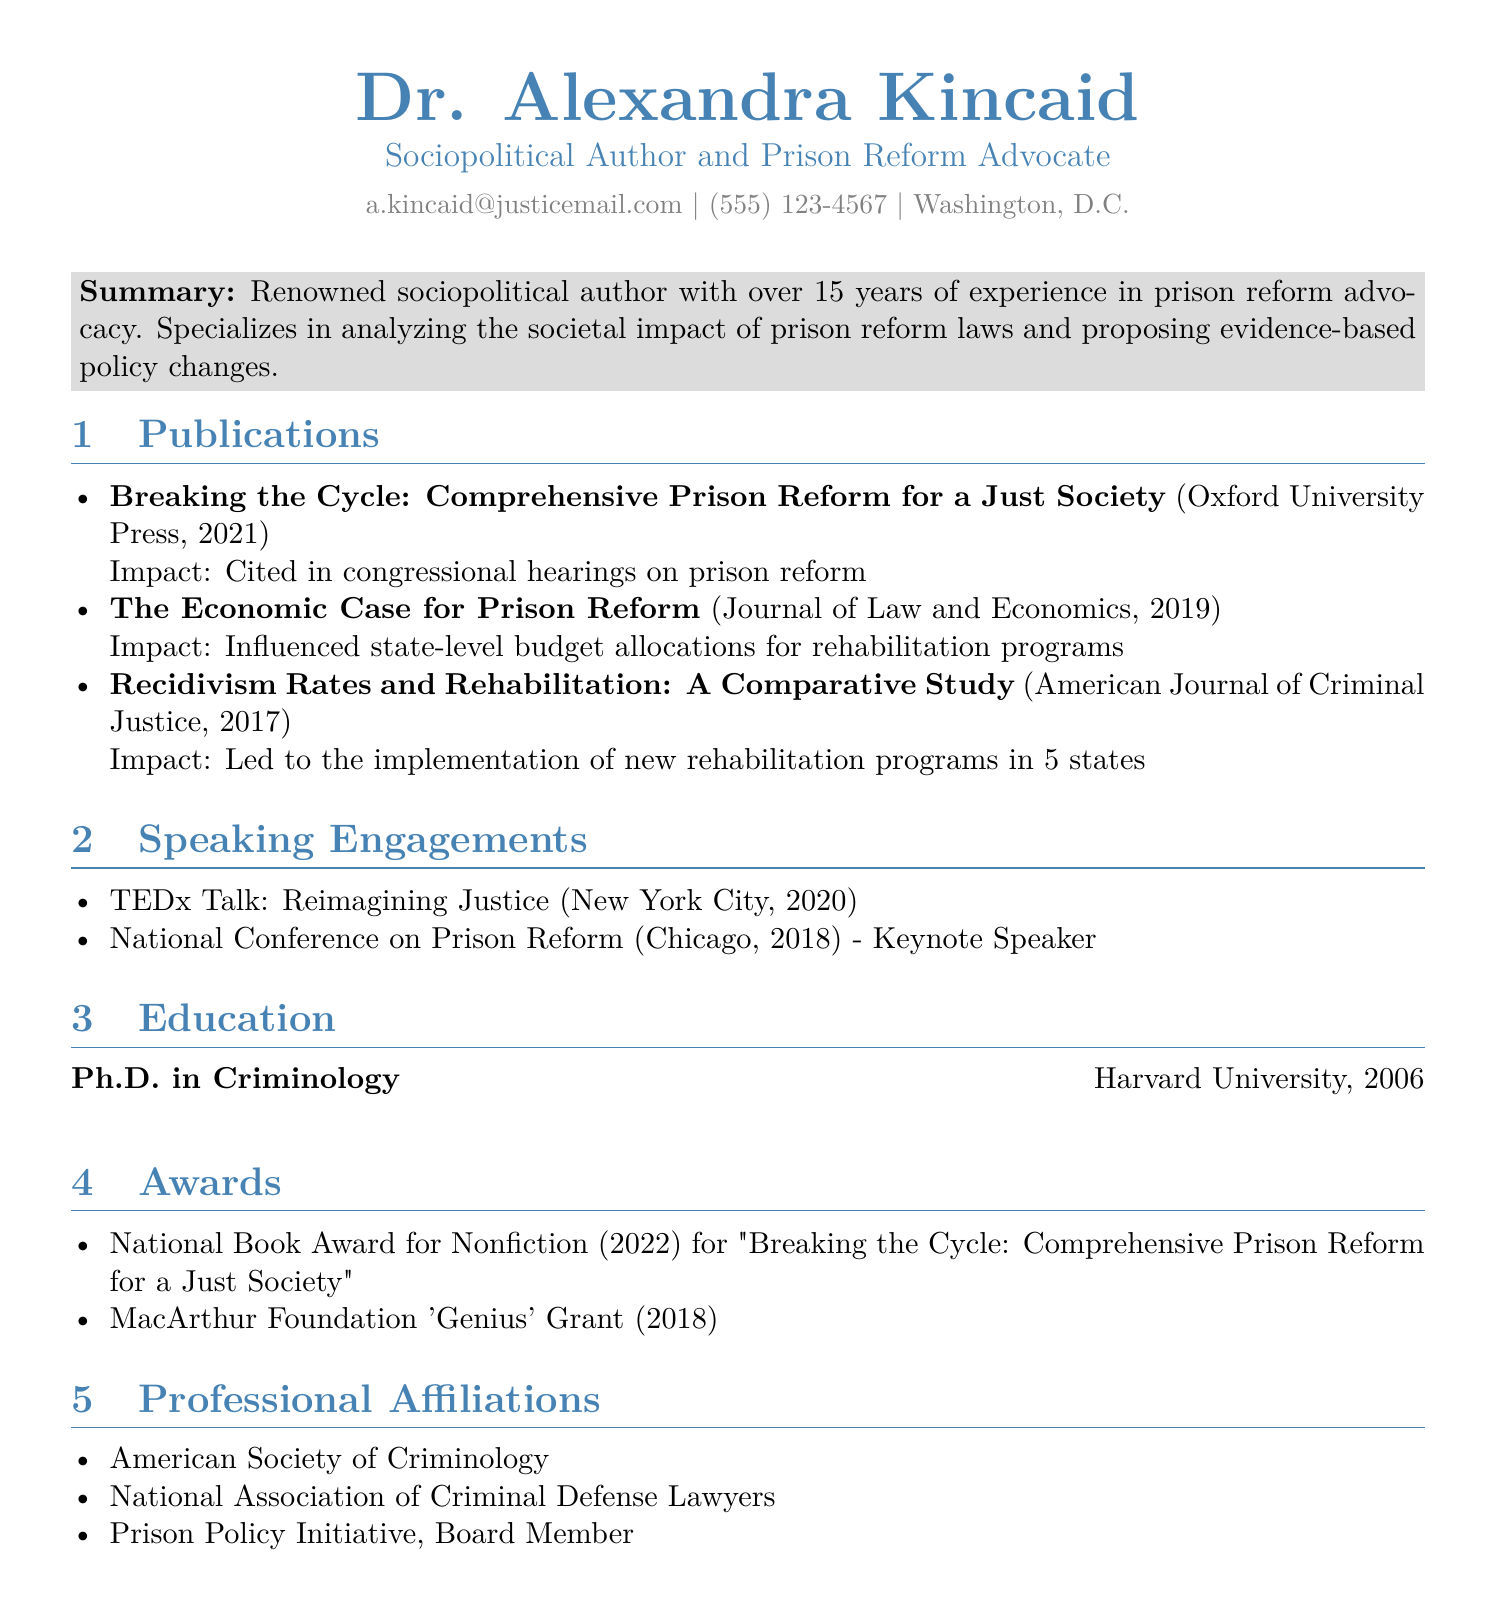What is Dr. Alexandra Kincaid's email address? The email address is found in the contact information of the document.
Answer: a.kincaid@justicemail.com In what year was the publication "Breaking the Cycle: Comprehensive Prison Reform for a Just Society" released? The year of publication is included in the publications section of the document.
Answer: 2021 What influential role did Dr. Kincaid hold in the National Conference on Prison Reform? The role is specified in the speaking engagements section.
Answer: Keynote Speaker How many years of experience does Dr. Kincaid have in prison reform advocacy? The summary provides this information based on the author's background.
Answer: 15 years Which award did Dr. Kincaid receive in 2022 for her work? The awards section lists this specific recognition achieved by the author.
Answer: National Book Award for Nonfiction What is the focus of Dr. Kincaid's Ph.D. degree? The education section indicates the field of study for her degree.
Answer: Criminology How many states implemented new rehabilitation programs following Dr. Kincaid's research? The impact of her publication in the document reveals this information.
Answer: 5 states Who is a board member of the Prison Policy Initiative? The professional affiliations section includes this detail about Dr. Kincaid.
Answer: Dr. Alexandra Kincaid 